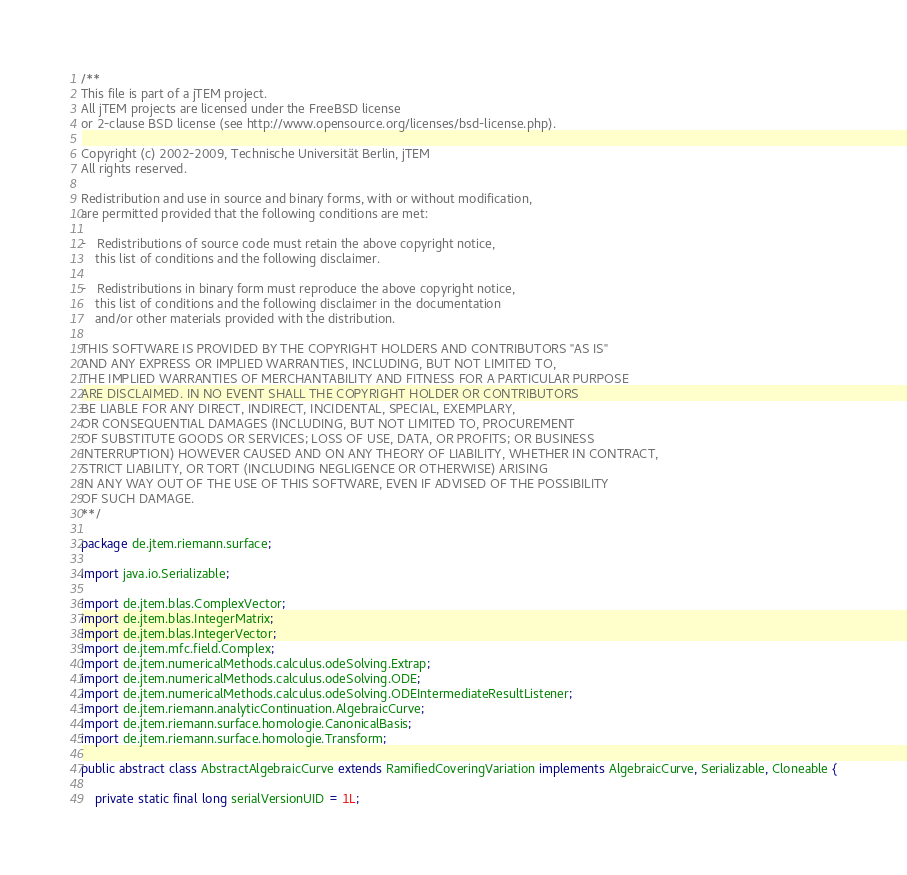Convert code to text. <code><loc_0><loc_0><loc_500><loc_500><_Java_>/**
This file is part of a jTEM project.
All jTEM projects are licensed under the FreeBSD license 
or 2-clause BSD license (see http://www.opensource.org/licenses/bsd-license.php). 

Copyright (c) 2002-2009, Technische Universität Berlin, jTEM
All rights reserved.

Redistribution and use in source and binary forms, with or without modification, 
are permitted provided that the following conditions are met:

-	Redistributions of source code must retain the above copyright notice, 
	this list of conditions and the following disclaimer.

-	Redistributions in binary form must reproduce the above copyright notice, 
	this list of conditions and the following disclaimer in the documentation 
	and/or other materials provided with the distribution.
 
THIS SOFTWARE IS PROVIDED BY THE COPYRIGHT HOLDERS AND CONTRIBUTORS "AS IS" 
AND ANY EXPRESS OR IMPLIED WARRANTIES, INCLUDING, BUT NOT LIMITED TO, 
THE IMPLIED WARRANTIES OF MERCHANTABILITY AND FITNESS FOR A PARTICULAR PURPOSE 
ARE DISCLAIMED. IN NO EVENT SHALL THE COPYRIGHT HOLDER OR CONTRIBUTORS 
BE LIABLE FOR ANY DIRECT, INDIRECT, INCIDENTAL, SPECIAL, EXEMPLARY, 
OR CONSEQUENTIAL DAMAGES (INCLUDING, BUT NOT LIMITED TO, PROCUREMENT 
OF SUBSTITUTE GOODS OR SERVICES; LOSS OF USE, DATA, OR PROFITS; OR BUSINESS 
INTERRUPTION) HOWEVER CAUSED AND ON ANY THEORY OF LIABILITY, WHETHER IN CONTRACT, 
STRICT LIABILITY, OR TORT (INCLUDING NEGLIGENCE OR OTHERWISE) ARISING 
IN ANY WAY OUT OF THE USE OF THIS SOFTWARE, EVEN IF ADVISED OF THE POSSIBILITY 
OF SUCH DAMAGE.
**/

package de.jtem.riemann.surface;

import java.io.Serializable;

import de.jtem.blas.ComplexVector;
import de.jtem.blas.IntegerMatrix;
import de.jtem.blas.IntegerVector;
import de.jtem.mfc.field.Complex;
import de.jtem.numericalMethods.calculus.odeSolving.Extrap;
import de.jtem.numericalMethods.calculus.odeSolving.ODE;
import de.jtem.numericalMethods.calculus.odeSolving.ODEIntermediateResultListener;
import de.jtem.riemann.analyticContinuation.AlgebraicCurve;
import de.jtem.riemann.surface.homologie.CanonicalBasis;
import de.jtem.riemann.surface.homologie.Transform;

public abstract class AbstractAlgebraicCurve extends RamifiedCoveringVariation implements AlgebraicCurve, Serializable, Cloneable {

	private static final long serialVersionUID = 1L;
</code> 